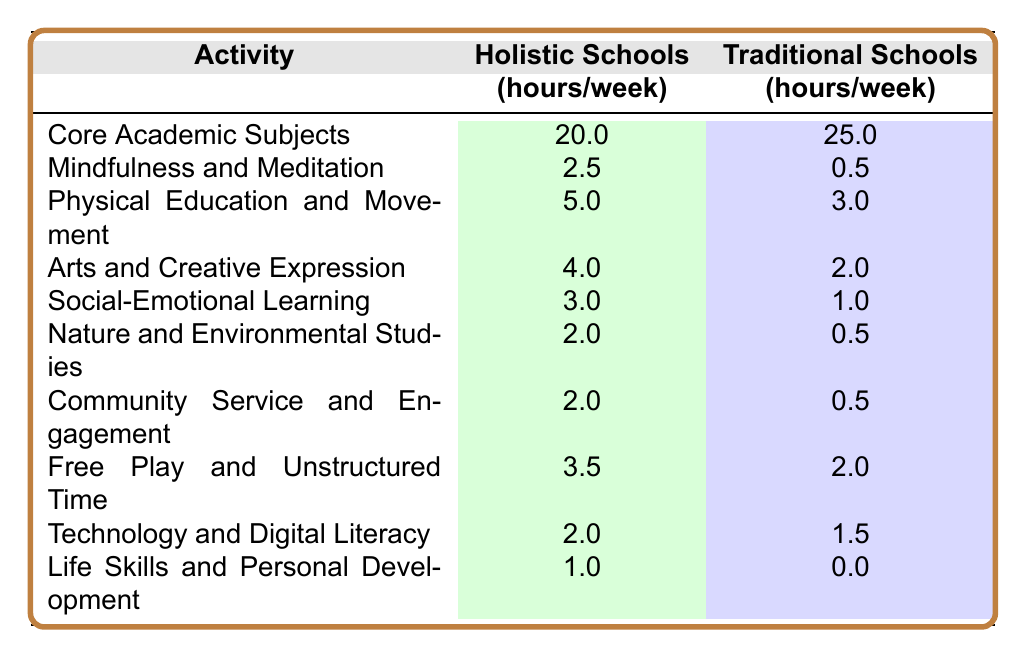What is the time spent on Mindfulness and Meditation in holistic schools? The table shows that holistic schools allocate 2.5 hours per week for Mindfulness and Meditation.
Answer: 2.5 hours How many more hours are dedicated to Core Academic Subjects in traditional schools compared to holistic schools? Traditional schools dedicate 25 hours to Core Academic Subjects, while holistic schools dedicate 20 hours. The difference is 25 - 20 = 5 hours.
Answer: 5 hours What is the total weekly time spent on Arts and Creative Expression across both school types? Holistic schools spend 4 hours on Arts and Creative Expression and traditional schools spend 2 hours. The total is 4 + 2 = 6 hours.
Answer: 6 hours Does traditional education include more time for Social-Emotional Learning than holistic education? Traditional schools allocate 1 hour for Social-Emotional Learning, while holistic schools allocate 3 hours, making it false that traditional education has more time.
Answer: No What is the difference in hours spent on Physical Education and Movement between holistic and traditional schools? Holistic schools dedicate 5 hours while traditional schools dedicate 3 hours. The difference is 5 - 3 = 2 hours.
Answer: 2 hours What percentage of time in holistic schools is spent on Community Service and Engagement compared to the total time spent on all activities listed for holistic schools? The total hours for holistic activities is 20 + 2.5 + 5 + 4 + 3 + 2 + 2 + 3.5 + 2 + 1 = 43 hours. Community Service and Engagement is 2 hours. The percentage is (2/43) * 100 ≈ 4.65%.
Answer: Approximately 4.65% In which activity do holistic schools allocate the least time? Reviewing the table values, Life Skills and Personal Development has the least hours at 1 hour in holistic schools.
Answer: Life Skills and Personal Development Is the total time spent on Technology and Digital Literacy greater in holistic or traditional schools? Holistic schools spend 2 hours and traditional schools spend 1.5 hours on Technology and Digital Literacy. Holistic schools spend more time.
Answer: Holistic schools How much total time is allocated to physical education and related activities in both school types combined? The table shows holistic schools have 5 hours and traditional schools have 3 hours for Physical Education and Movement. The total is 5 + 3 = 8 hours.
Answer: 8 hours What is the combined time spent on Mindfulness, Community Service, and Nature studies in holistic schools? The time dedicated to Mindfulness is 2.5 hours, Community Service is 2 hours, and Nature Studies is 2 hours. The combined total is 2.5 + 2 + 2 = 6.5 hours.
Answer: 6.5 hours 